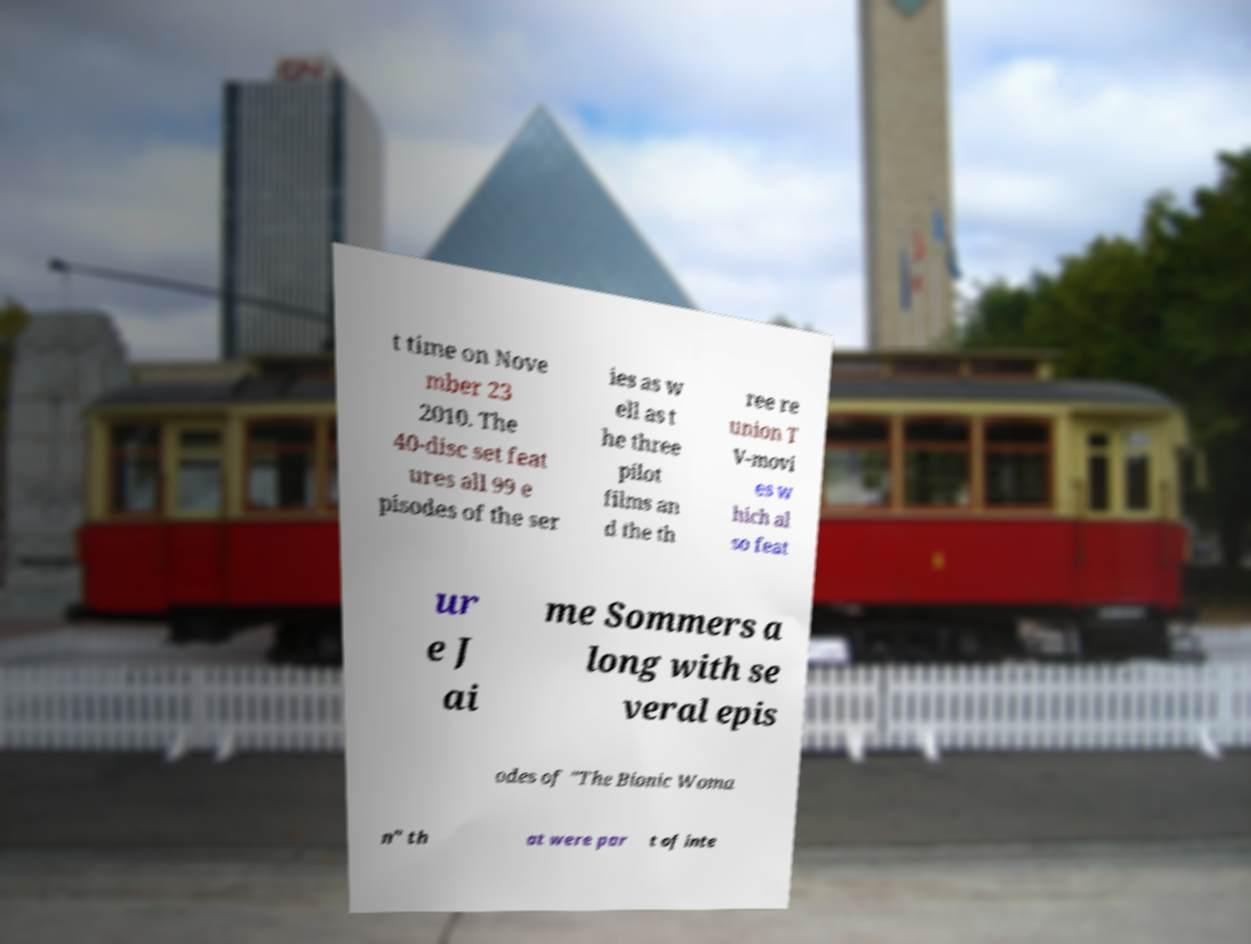I need the written content from this picture converted into text. Can you do that? t time on Nove mber 23 2010. The 40-disc set feat ures all 99 e pisodes of the ser ies as w ell as t he three pilot films an d the th ree re union T V-movi es w hich al so feat ur e J ai me Sommers a long with se veral epis odes of "The Bionic Woma n" th at were par t of inte 